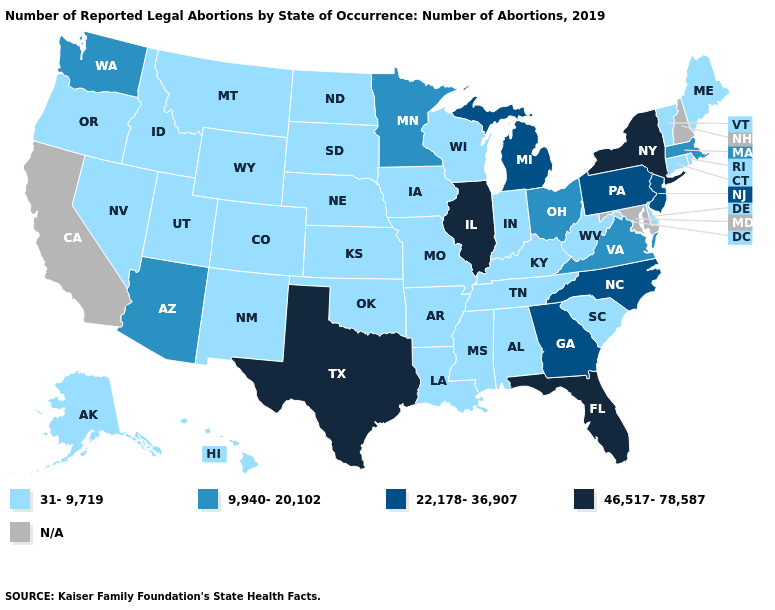Does the map have missing data?
Answer briefly. Yes. What is the highest value in states that border Wisconsin?
Quick response, please. 46,517-78,587. What is the lowest value in the Northeast?
Write a very short answer. 31-9,719. What is the lowest value in states that border Georgia?
Answer briefly. 31-9,719. Which states have the lowest value in the USA?
Keep it brief. Alabama, Alaska, Arkansas, Colorado, Connecticut, Delaware, Hawaii, Idaho, Indiana, Iowa, Kansas, Kentucky, Louisiana, Maine, Mississippi, Missouri, Montana, Nebraska, Nevada, New Mexico, North Dakota, Oklahoma, Oregon, Rhode Island, South Carolina, South Dakota, Tennessee, Utah, Vermont, West Virginia, Wisconsin, Wyoming. Is the legend a continuous bar?
Keep it brief. No. Does New York have the highest value in the USA?
Keep it brief. Yes. What is the lowest value in the West?
Short answer required. 31-9,719. Name the states that have a value in the range 9,940-20,102?
Keep it brief. Arizona, Massachusetts, Minnesota, Ohio, Virginia, Washington. Name the states that have a value in the range 9,940-20,102?
Short answer required. Arizona, Massachusetts, Minnesota, Ohio, Virginia, Washington. What is the highest value in the South ?
Concise answer only. 46,517-78,587. Name the states that have a value in the range 31-9,719?
Write a very short answer. Alabama, Alaska, Arkansas, Colorado, Connecticut, Delaware, Hawaii, Idaho, Indiana, Iowa, Kansas, Kentucky, Louisiana, Maine, Mississippi, Missouri, Montana, Nebraska, Nevada, New Mexico, North Dakota, Oklahoma, Oregon, Rhode Island, South Carolina, South Dakota, Tennessee, Utah, Vermont, West Virginia, Wisconsin, Wyoming. Among the states that border Florida , does Alabama have the lowest value?
Short answer required. Yes. What is the value of Utah?
Short answer required. 31-9,719. Name the states that have a value in the range 31-9,719?
Short answer required. Alabama, Alaska, Arkansas, Colorado, Connecticut, Delaware, Hawaii, Idaho, Indiana, Iowa, Kansas, Kentucky, Louisiana, Maine, Mississippi, Missouri, Montana, Nebraska, Nevada, New Mexico, North Dakota, Oklahoma, Oregon, Rhode Island, South Carolina, South Dakota, Tennessee, Utah, Vermont, West Virginia, Wisconsin, Wyoming. 